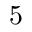<formula> <loc_0><loc_0><loc_500><loc_500>5</formula> 